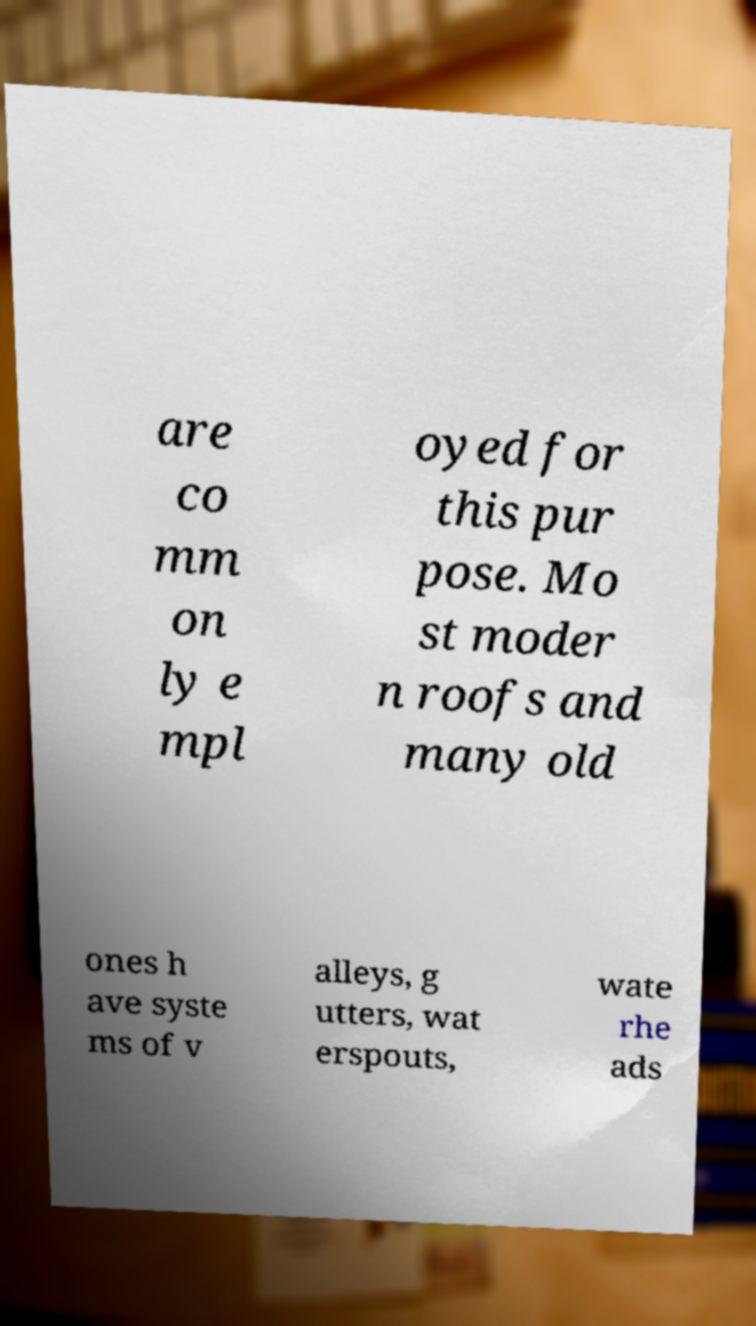Can you read and provide the text displayed in the image?This photo seems to have some interesting text. Can you extract and type it out for me? are co mm on ly e mpl oyed for this pur pose. Mo st moder n roofs and many old ones h ave syste ms of v alleys, g utters, wat erspouts, wate rhe ads 